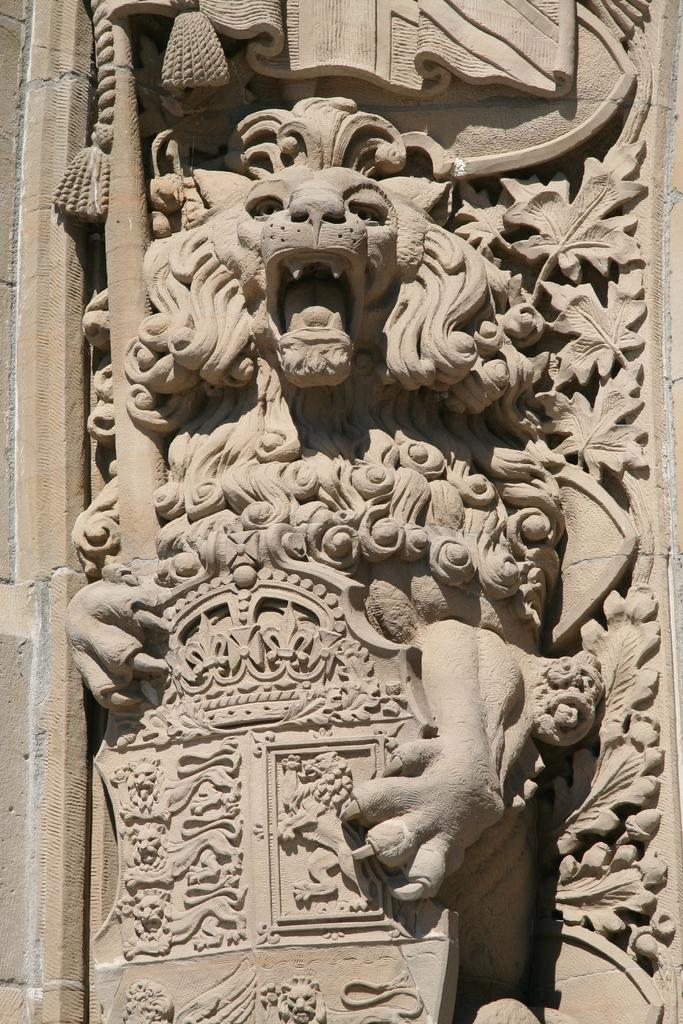What is the main subject of the image? There is a sculpture in the image. What type of dress is the sculpture wearing in the image? The sculpture is not wearing a dress, as it is an inanimate object and does not have clothing. 